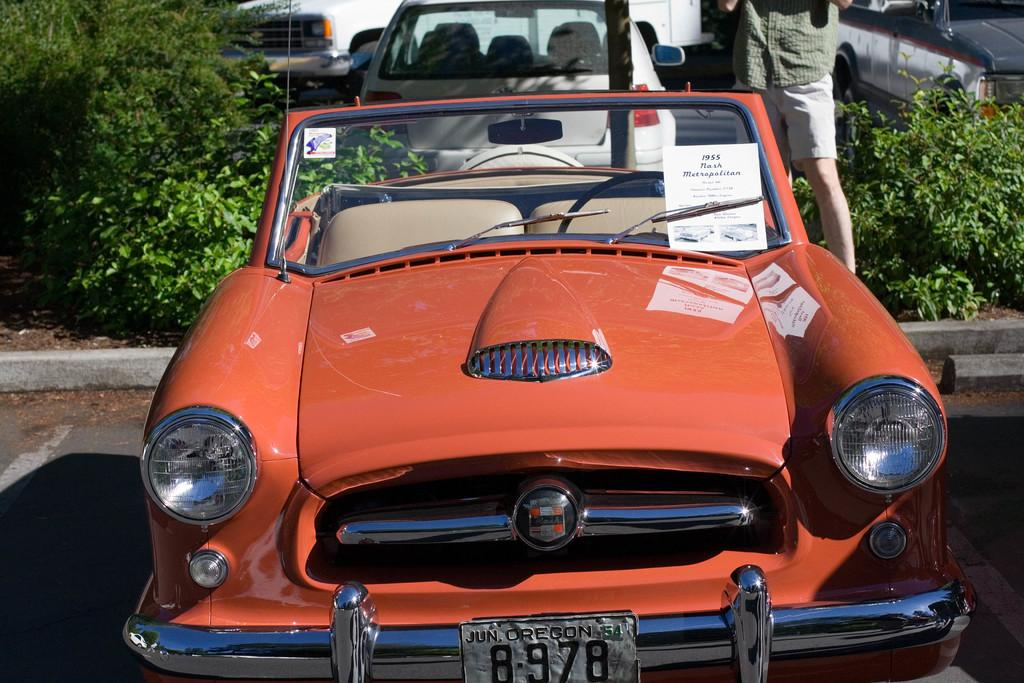What type of vehicles can be seen in the image? There are cars in the image. What is the color of the paper visible in the image? The paper is white-colored. What else is present in the image besides cars and paper? There are plants in the image. What is written on the paper? Something is written on the paper. Can you describe the person standing in the image? There is a person standing in the image. What type of wool is being used by the judge sitting on the sofa in the image? There is no judge or sofa present in the image. 